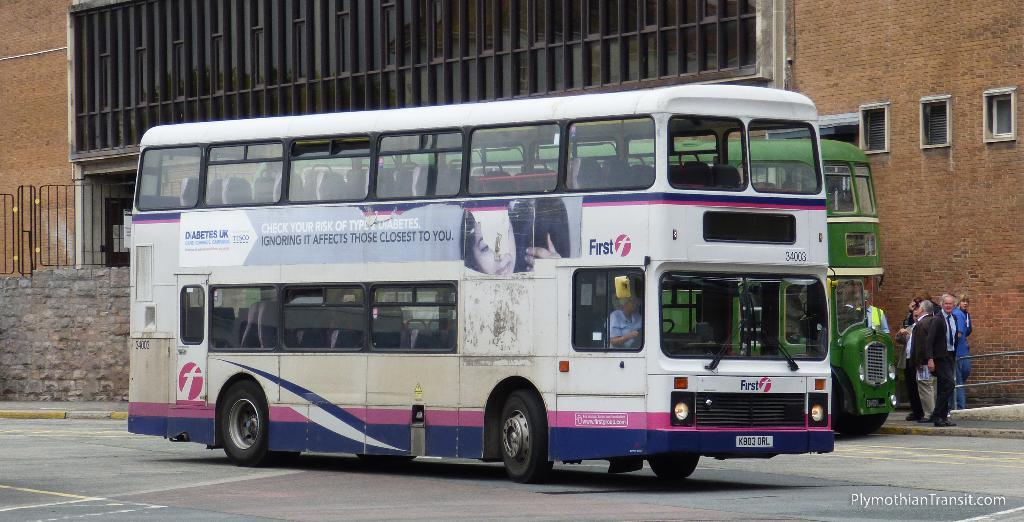<image>
Write a terse but informative summary of the picture. A female driver drives a bus with an advertisement for Diabetes UK. 